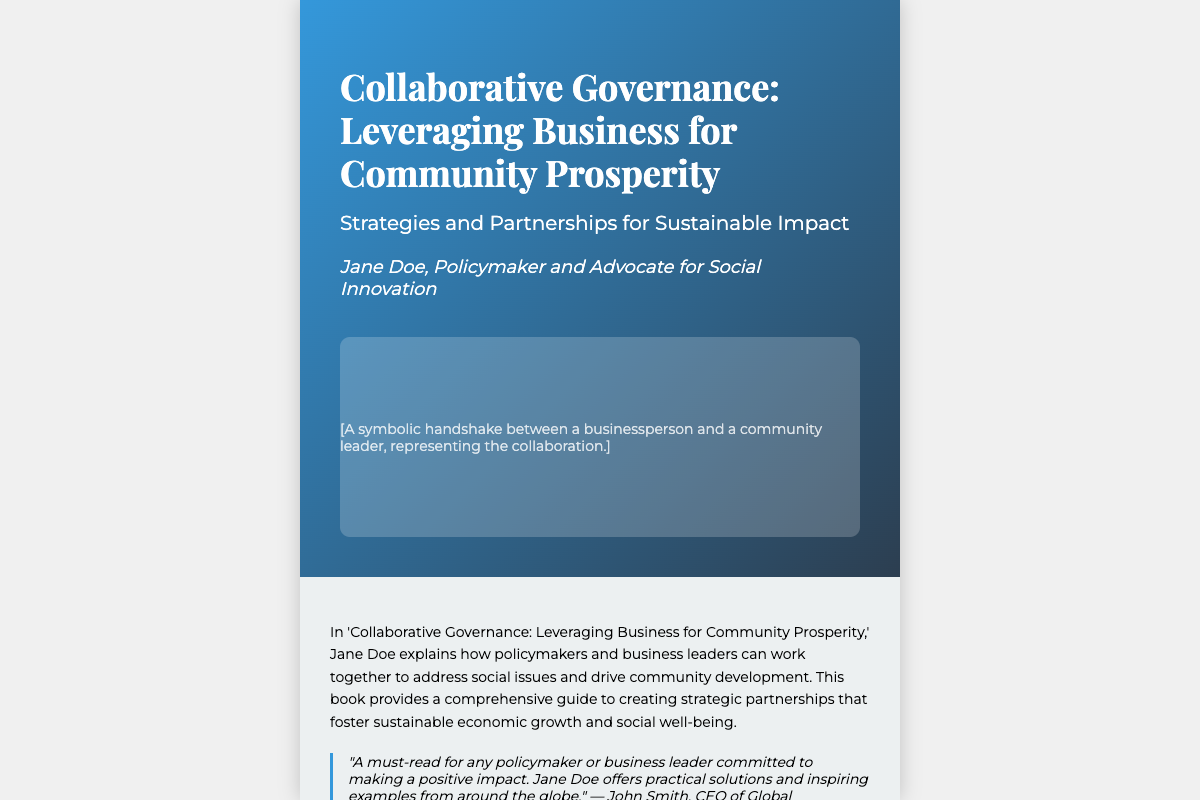What is the title of the book? The title is prominently displayed on the cover, indicating the main focus of the book.
Answer: Collaborative Governance: Leveraging Business for Community Prosperity Who is the author of the book? The author's name is stated under the title, identifying the individual responsible for the content.
Answer: Jane Doe What is the ISBN number? The ISBN is provided at the end of the back cover, allowing for easy identification and cataloging of the book.
Answer: 978-1-23456-789-0 What type of strategies does the book discuss? The subtitle clarifies the focus on strategies related to community impact, providing insight into the book's content.
Answer: Sustainable Impact Who provided a positive review mentioning practical solutions? The praise section includes a notable individual's name who endorses the book, emphasizing its value to readers.
Answer: John Smith What theme is represented by the symbolic handshake image? The description refers to the collaborative theme that the book centers around, illustrating the main partnership concept.
Answer: Collaboration What is the main focus of 'Collaborative Governance' according to the blurb? The blurb summarizes the book's aim, indicating its relevance to community development and social issues.
Answer: Address social issues Which organization published the book? The publisher's name appears at the end of the back cover, important for recognizing the source of publication.
Answer: Social Impact Press 